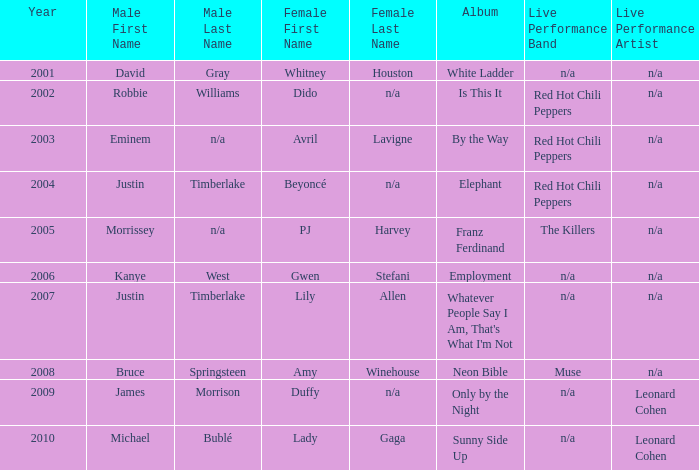Who is the male partner for amy winehouse? Bruce Springsteen. 